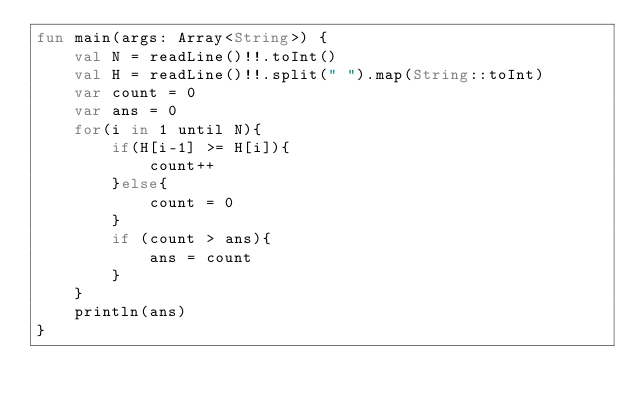Convert code to text. <code><loc_0><loc_0><loc_500><loc_500><_Kotlin_>fun main(args: Array<String>) {
    val N = readLine()!!.toInt()
    val H = readLine()!!.split(" ").map(String::toInt)
    var count = 0
    var ans = 0
    for(i in 1 until N){
        if(H[i-1] >= H[i]){
            count++
        }else{
            count = 0
        }
        if (count > ans){
            ans = count
        }
    }
    println(ans)
}</code> 